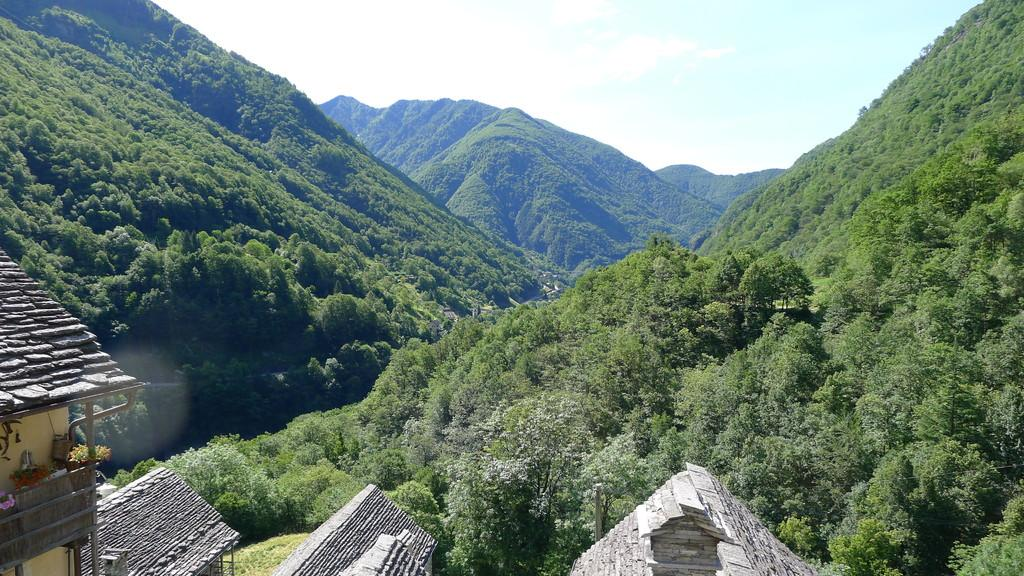What type of vegetation can be seen in the image? There are green color trees in the image. What is visible at the top of the image? The sky is visible at the top of the image. What type of skirt is the company wearing in the image? There is no company or skirt present in the image; it features green color trees and the sky. How many brothers are visible in the image? There are no brothers present in the image. 